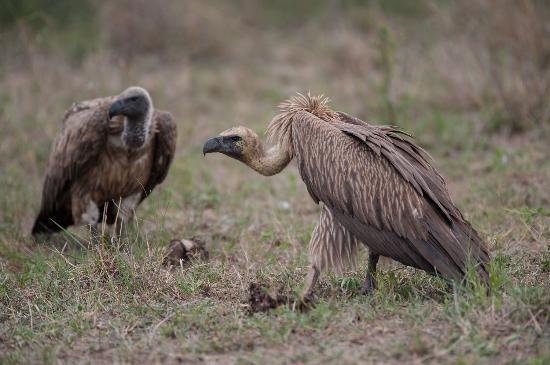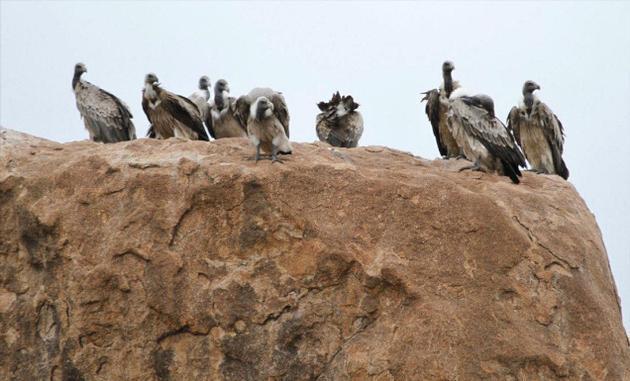The first image is the image on the left, the second image is the image on the right. Analyze the images presented: Is the assertion "A single bird is landing with its wings spread in the image on the right." valid? Answer yes or no. No. The first image is the image on the left, the second image is the image on the right. Assess this claim about the two images: "An image shows a group of vultures perched on something that is elevated.". Correct or not? Answer yes or no. Yes. 